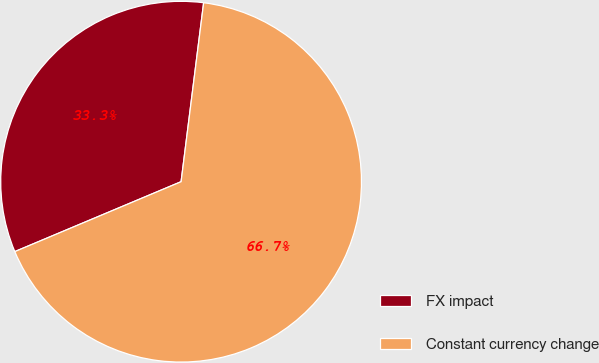<chart> <loc_0><loc_0><loc_500><loc_500><pie_chart><fcel>FX impact<fcel>Constant currency change<nl><fcel>33.33%<fcel>66.67%<nl></chart> 